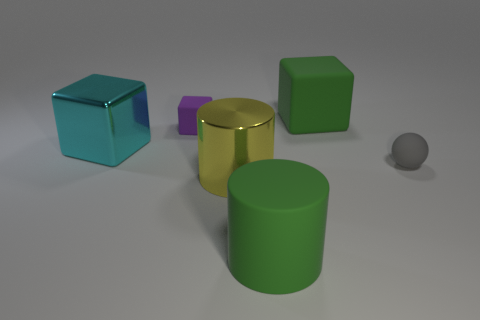Add 2 big matte things. How many objects exist? 8 Subtract all cylinders. How many objects are left? 4 Add 1 large cyan rubber spheres. How many large cyan rubber spheres exist? 1 Subtract 0 yellow spheres. How many objects are left? 6 Subtract all purple matte cubes. Subtract all tiny purple metallic things. How many objects are left? 5 Add 2 small spheres. How many small spheres are left? 3 